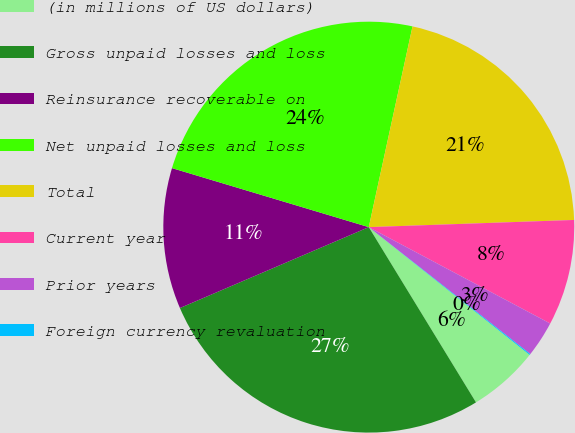Convert chart to OTSL. <chart><loc_0><loc_0><loc_500><loc_500><pie_chart><fcel>(in millions of US dollars)<fcel>Gross unpaid losses and loss<fcel>Reinsurance recoverable on<fcel>Net unpaid losses and loss<fcel>Total<fcel>Current year<fcel>Prior years<fcel>Foreign currency revaluation<nl><fcel>5.58%<fcel>27.3%<fcel>11.08%<fcel>23.78%<fcel>21.03%<fcel>8.33%<fcel>2.83%<fcel>0.08%<nl></chart> 